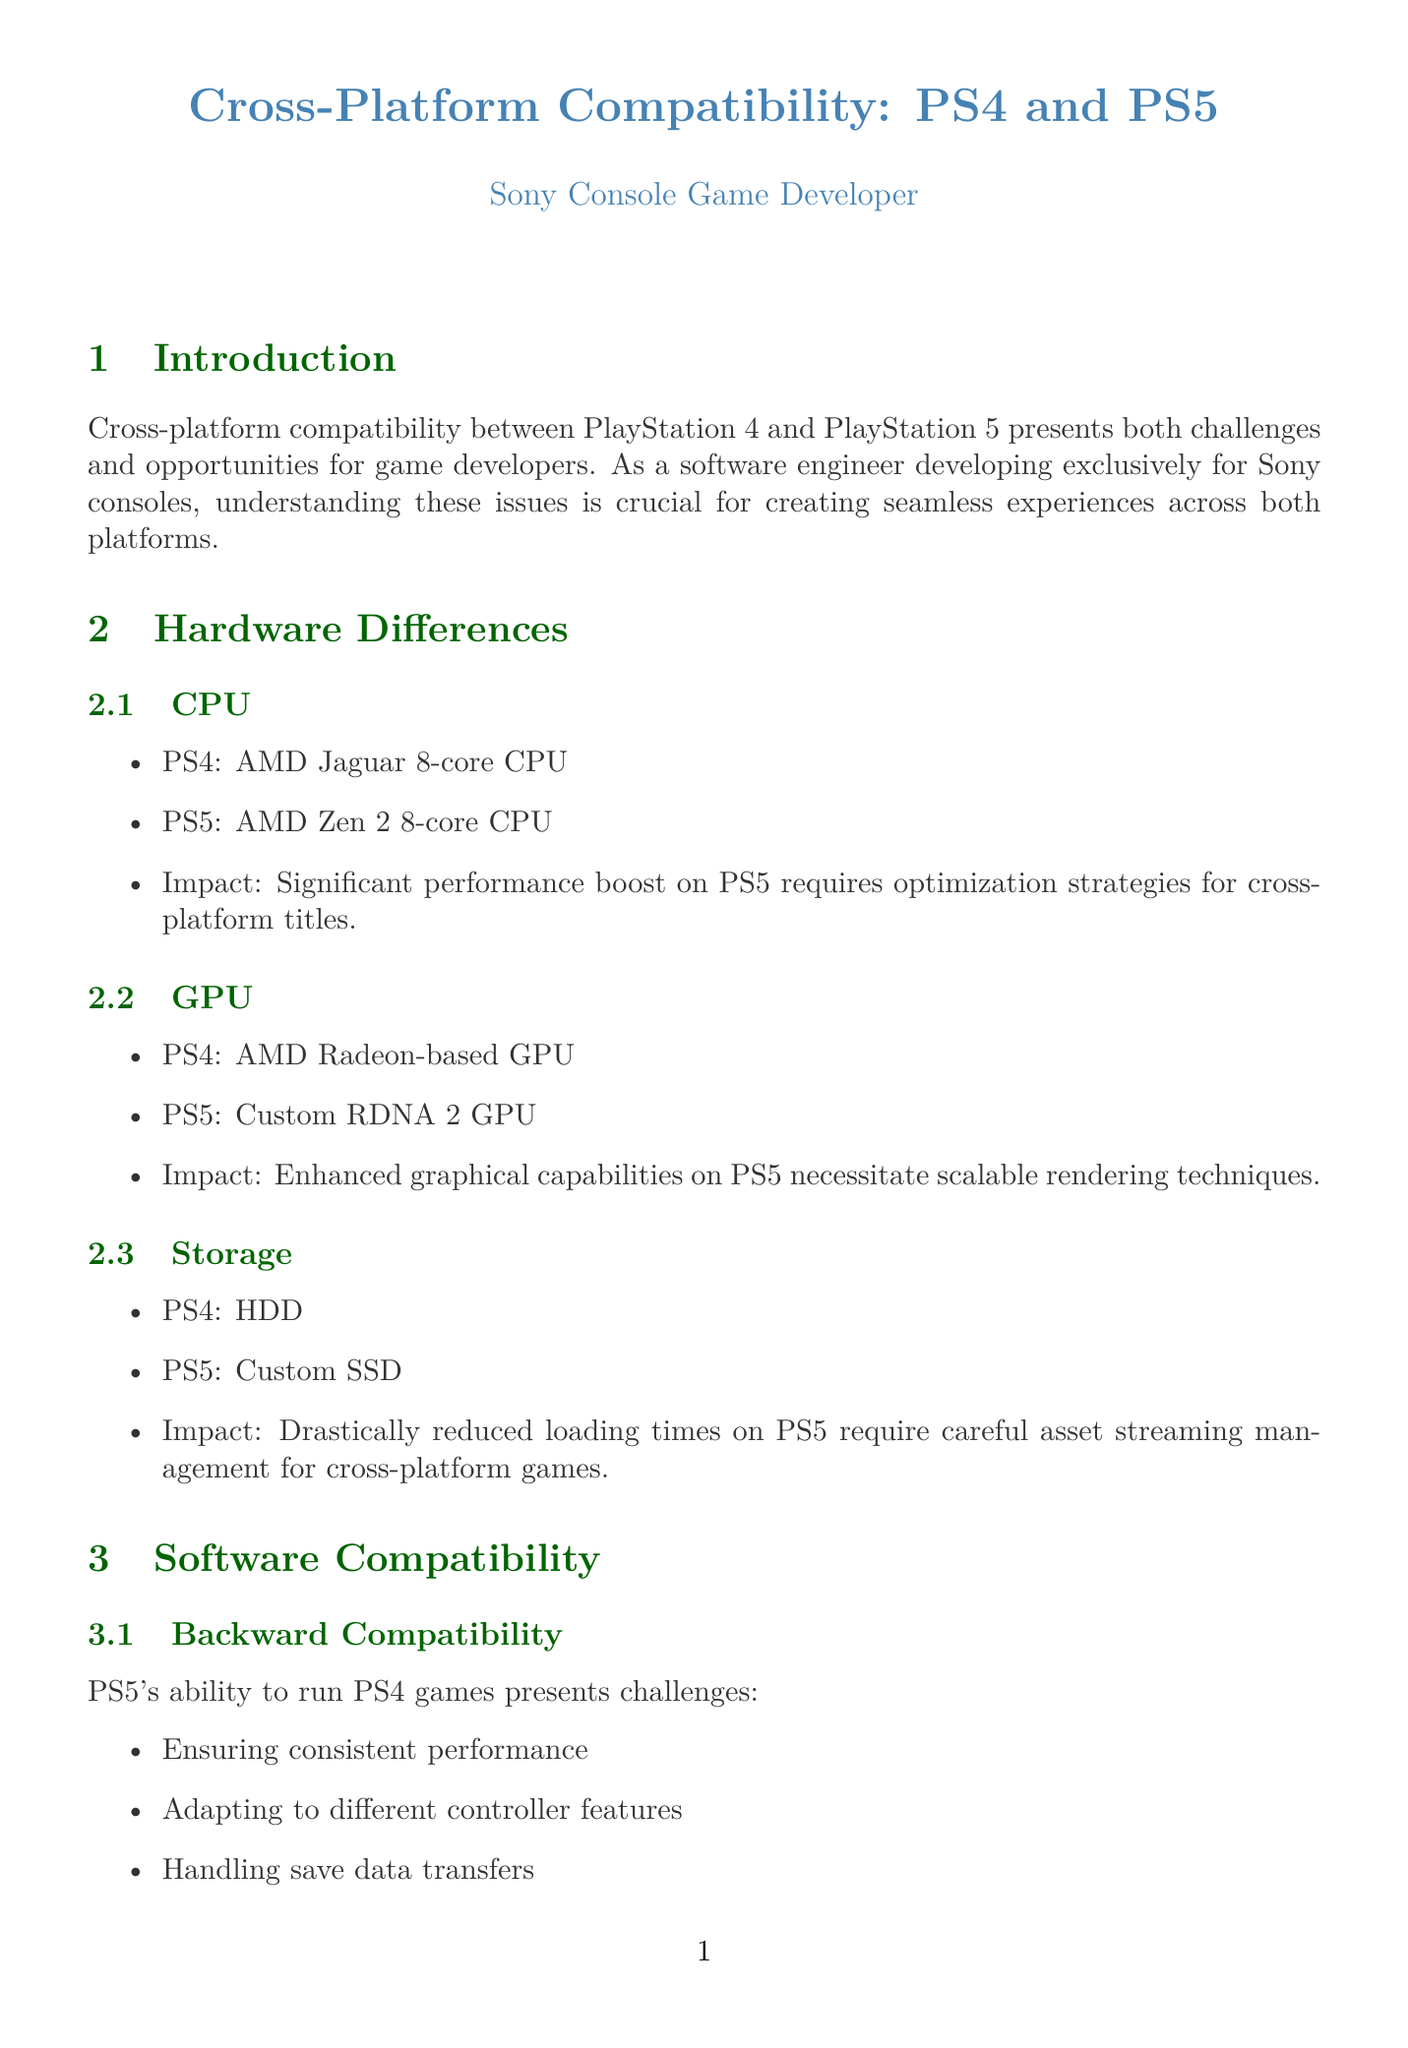What is the CPU in PS4? The document states that the PS4 has an AMD Jaguar 8-core CPU.
Answer: AMD Jaguar 8-core CPU What is the impact of enhanced graphical capabilities on PS5? The document mentions that enhanced graphical capabilities on PS5 necessitate scalable rendering techniques.
Answer: Scalable rendering techniques What are the common development tools listed? The report provides a list of common tools, including PlayStation SDK, PhyreEngine, and PlayStation VR SDK.
Answer: PlayStation SDK, PhyreEngine, PlayStation VR SDK What technique is used for reducing loading times? The document indicates that data compression is the technique used to reduce loading times.
Answer: Data Compression What is an example of a PS5 exclusive feature in Ratchet and Clank: Rift Apart? The document cites instantaneous dimension hopping as a PS5 exclusive feature in the mentioned game.
Answer: Instantaneous dimension hopping What is a challenge in cross-generation multiplayer? The document lists balancing performance disparities as one of the challenges in cross-generation multiplayer.
Answer: Balancing performance disparities What is the potential impact of PlayStation Now? According to the document, PlayStation Now has the potential for platform-agnostic game streaming.
Answer: Platform-agnostic game streaming What technique is mentioned for adaptive input management? The report specifies the Adaptive Input System as the technique for input handling.
Answer: Adaptive Input System 